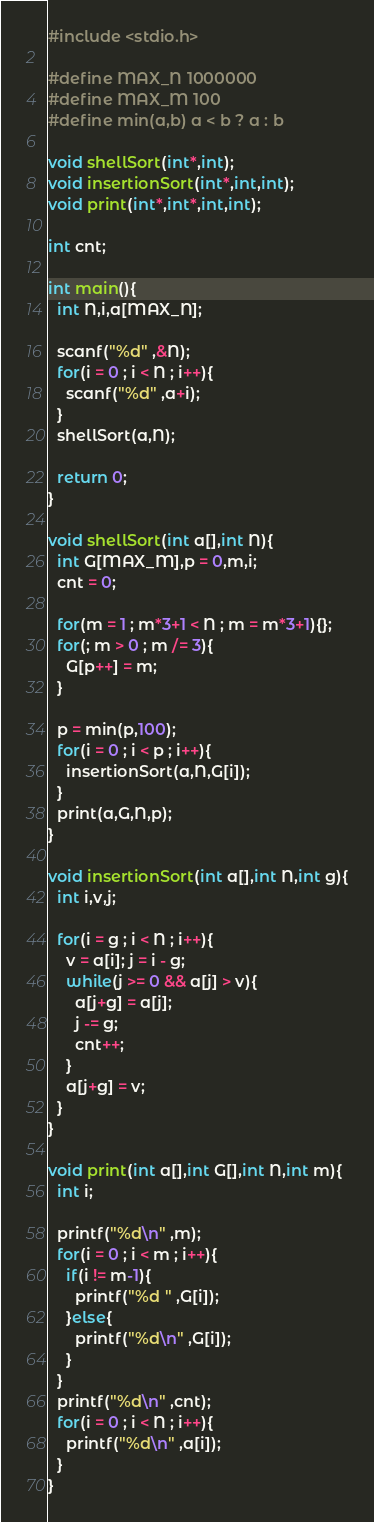<code> <loc_0><loc_0><loc_500><loc_500><_C_>#include <stdio.h>

#define MAX_N 1000000
#define MAX_M 100
#define min(a,b) a < b ? a : b

void shellSort(int*,int);
void insertionSort(int*,int,int);
void print(int*,int*,int,int);

int cnt;

int main(){
  int N,i,a[MAX_N];

  scanf("%d" ,&N);
  for(i = 0 ; i < N ; i++){
    scanf("%d" ,a+i);
  }
  shellSort(a,N);

  return 0;
}

void shellSort(int a[],int N){
  int G[MAX_M],p = 0,m,i;
  cnt = 0;

  for(m = 1 ; m*3+1 < N ; m = m*3+1){};
  for(; m > 0 ; m /= 3){
    G[p++] = m;
  }

  p = min(p,100);
  for(i = 0 ; i < p ; i++){
    insertionSort(a,N,G[i]);
  }
  print(a,G,N,p);
}

void insertionSort(int a[],int N,int g){
  int i,v,j;

  for(i = g ; i < N ; i++){
    v = a[i]; j = i - g;
    while(j >= 0 && a[j] > v){
      a[j+g] = a[j];
      j -= g;
      cnt++;
    }
    a[j+g] = v;
  }
}

void print(int a[],int G[],int N,int m){
  int i;
  
  printf("%d\n" ,m);
  for(i = 0 ; i < m ; i++){
    if(i != m-1){
      printf("%d " ,G[i]);
    }else{
      printf("%d\n" ,G[i]);
    }
  }
  printf("%d\n" ,cnt);
  for(i = 0 ; i < N ; i++){
    printf("%d\n" ,a[i]);
  }
}
</code> 